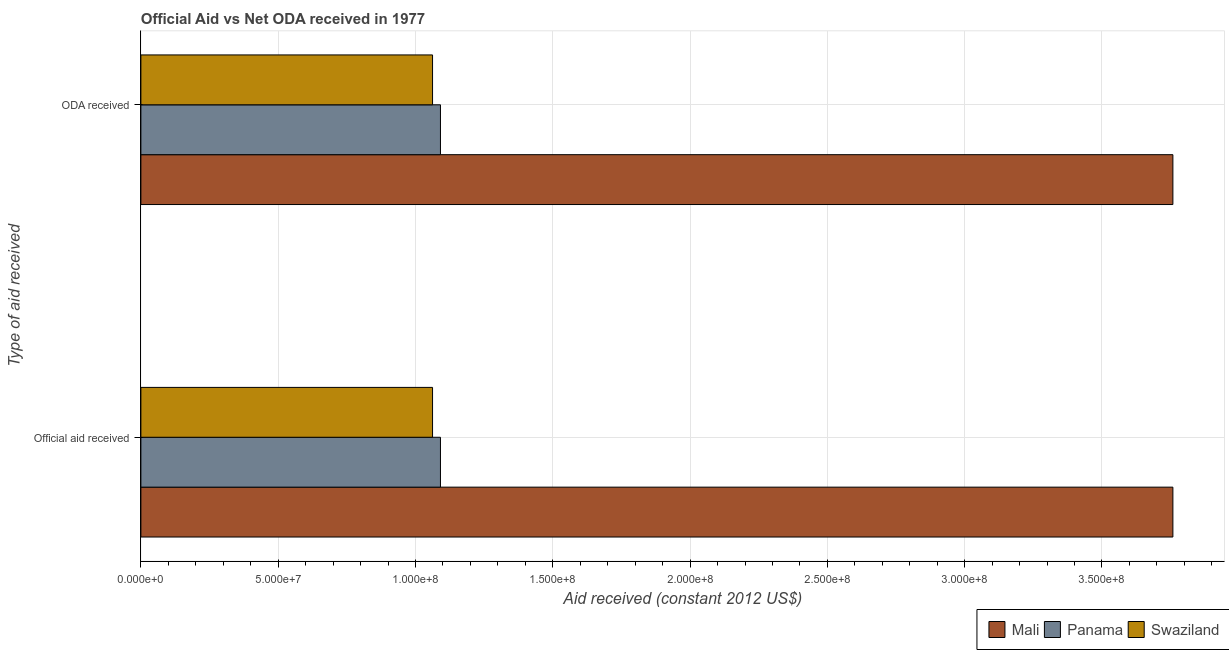How many groups of bars are there?
Your response must be concise. 2. Are the number of bars on each tick of the Y-axis equal?
Make the answer very short. Yes. What is the label of the 2nd group of bars from the top?
Provide a short and direct response. Official aid received. What is the official aid received in Mali?
Your response must be concise. 3.76e+08. Across all countries, what is the maximum official aid received?
Your answer should be very brief. 3.76e+08. Across all countries, what is the minimum oda received?
Offer a very short reply. 1.06e+08. In which country was the official aid received maximum?
Provide a short and direct response. Mali. In which country was the official aid received minimum?
Your response must be concise. Swaziland. What is the total oda received in the graph?
Ensure brevity in your answer.  5.91e+08. What is the difference between the official aid received in Panama and that in Swaziland?
Ensure brevity in your answer.  2.88e+06. What is the difference between the oda received in Mali and the official aid received in Panama?
Offer a very short reply. 2.67e+08. What is the average oda received per country?
Offer a very short reply. 1.97e+08. What is the difference between the official aid received and oda received in Swaziland?
Provide a succinct answer. 0. In how many countries, is the oda received greater than 30000000 US$?
Provide a succinct answer. 3. What is the ratio of the oda received in Mali to that in Swaziland?
Keep it short and to the point. 3.54. In how many countries, is the oda received greater than the average oda received taken over all countries?
Your answer should be compact. 1. What does the 2nd bar from the top in Official aid received represents?
Your response must be concise. Panama. What does the 3rd bar from the bottom in Official aid received represents?
Ensure brevity in your answer.  Swaziland. Are all the bars in the graph horizontal?
Your answer should be very brief. Yes. How many countries are there in the graph?
Provide a short and direct response. 3. Are the values on the major ticks of X-axis written in scientific E-notation?
Provide a short and direct response. Yes. Does the graph contain any zero values?
Offer a very short reply. No. How many legend labels are there?
Provide a short and direct response. 3. What is the title of the graph?
Your answer should be compact. Official Aid vs Net ODA received in 1977 . Does "Oman" appear as one of the legend labels in the graph?
Give a very brief answer. No. What is the label or title of the X-axis?
Ensure brevity in your answer.  Aid received (constant 2012 US$). What is the label or title of the Y-axis?
Keep it short and to the point. Type of aid received. What is the Aid received (constant 2012 US$) in Mali in Official aid received?
Your answer should be compact. 3.76e+08. What is the Aid received (constant 2012 US$) of Panama in Official aid received?
Your response must be concise. 1.09e+08. What is the Aid received (constant 2012 US$) in Swaziland in Official aid received?
Provide a short and direct response. 1.06e+08. What is the Aid received (constant 2012 US$) in Mali in ODA received?
Provide a succinct answer. 3.76e+08. What is the Aid received (constant 2012 US$) of Panama in ODA received?
Provide a succinct answer. 1.09e+08. What is the Aid received (constant 2012 US$) in Swaziland in ODA received?
Offer a terse response. 1.06e+08. Across all Type of aid received, what is the maximum Aid received (constant 2012 US$) in Mali?
Make the answer very short. 3.76e+08. Across all Type of aid received, what is the maximum Aid received (constant 2012 US$) in Panama?
Provide a succinct answer. 1.09e+08. Across all Type of aid received, what is the maximum Aid received (constant 2012 US$) in Swaziland?
Offer a terse response. 1.06e+08. Across all Type of aid received, what is the minimum Aid received (constant 2012 US$) of Mali?
Keep it short and to the point. 3.76e+08. Across all Type of aid received, what is the minimum Aid received (constant 2012 US$) in Panama?
Give a very brief answer. 1.09e+08. Across all Type of aid received, what is the minimum Aid received (constant 2012 US$) of Swaziland?
Keep it short and to the point. 1.06e+08. What is the total Aid received (constant 2012 US$) in Mali in the graph?
Your answer should be very brief. 7.52e+08. What is the total Aid received (constant 2012 US$) in Panama in the graph?
Provide a short and direct response. 2.18e+08. What is the total Aid received (constant 2012 US$) in Swaziland in the graph?
Give a very brief answer. 2.12e+08. What is the difference between the Aid received (constant 2012 US$) in Mali in Official aid received and that in ODA received?
Keep it short and to the point. 0. What is the difference between the Aid received (constant 2012 US$) in Mali in Official aid received and the Aid received (constant 2012 US$) in Panama in ODA received?
Your answer should be compact. 2.67e+08. What is the difference between the Aid received (constant 2012 US$) in Mali in Official aid received and the Aid received (constant 2012 US$) in Swaziland in ODA received?
Keep it short and to the point. 2.70e+08. What is the difference between the Aid received (constant 2012 US$) in Panama in Official aid received and the Aid received (constant 2012 US$) in Swaziland in ODA received?
Give a very brief answer. 2.88e+06. What is the average Aid received (constant 2012 US$) of Mali per Type of aid received?
Make the answer very short. 3.76e+08. What is the average Aid received (constant 2012 US$) of Panama per Type of aid received?
Make the answer very short. 1.09e+08. What is the average Aid received (constant 2012 US$) of Swaziland per Type of aid received?
Make the answer very short. 1.06e+08. What is the difference between the Aid received (constant 2012 US$) of Mali and Aid received (constant 2012 US$) of Panama in Official aid received?
Your answer should be compact. 2.67e+08. What is the difference between the Aid received (constant 2012 US$) of Mali and Aid received (constant 2012 US$) of Swaziland in Official aid received?
Provide a short and direct response. 2.70e+08. What is the difference between the Aid received (constant 2012 US$) in Panama and Aid received (constant 2012 US$) in Swaziland in Official aid received?
Offer a terse response. 2.88e+06. What is the difference between the Aid received (constant 2012 US$) in Mali and Aid received (constant 2012 US$) in Panama in ODA received?
Offer a terse response. 2.67e+08. What is the difference between the Aid received (constant 2012 US$) in Mali and Aid received (constant 2012 US$) in Swaziland in ODA received?
Your answer should be compact. 2.70e+08. What is the difference between the Aid received (constant 2012 US$) of Panama and Aid received (constant 2012 US$) of Swaziland in ODA received?
Your answer should be compact. 2.88e+06. What is the ratio of the Aid received (constant 2012 US$) in Panama in Official aid received to that in ODA received?
Offer a very short reply. 1. What is the difference between the highest and the second highest Aid received (constant 2012 US$) of Mali?
Your answer should be compact. 0. What is the difference between the highest and the second highest Aid received (constant 2012 US$) in Panama?
Provide a short and direct response. 0. What is the difference between the highest and the lowest Aid received (constant 2012 US$) of Mali?
Your answer should be compact. 0. What is the difference between the highest and the lowest Aid received (constant 2012 US$) of Swaziland?
Ensure brevity in your answer.  0. 